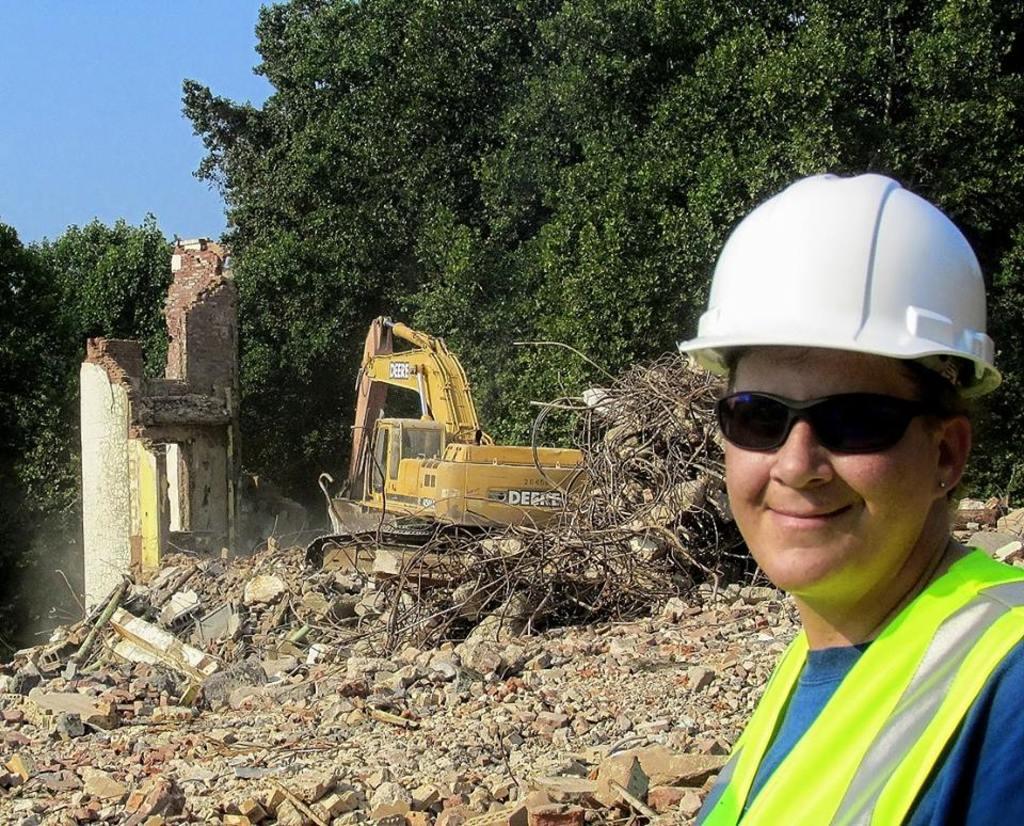Could you give a brief overview of what you see in this image? In the bottom right corner of the image a person is standing and smiling. Behind her there are some trees and stones. In the middle of the image there is a excavator. In the top left side of the image there is sky. 